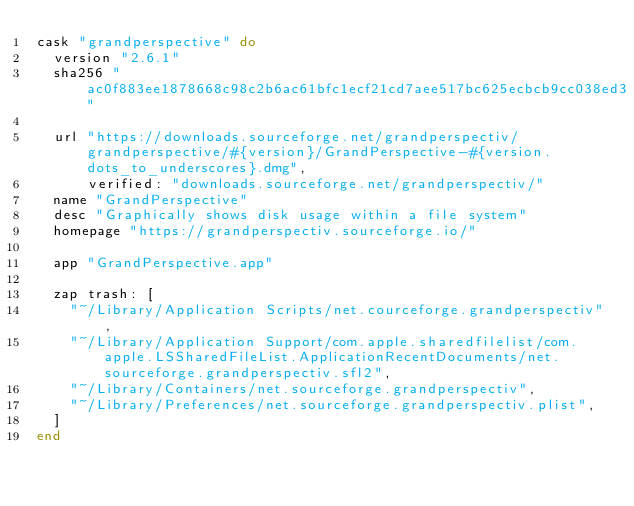<code> <loc_0><loc_0><loc_500><loc_500><_Ruby_>cask "grandperspective" do
  version "2.6.1"
  sha256 "ac0f883ee1878668c98c2b6ac61bfc1ecf21cd7aee517bc625ecbcb9cc038ed3"

  url "https://downloads.sourceforge.net/grandperspectiv/grandperspective/#{version}/GrandPerspective-#{version.dots_to_underscores}.dmg",
      verified: "downloads.sourceforge.net/grandperspectiv/"
  name "GrandPerspective"
  desc "Graphically shows disk usage within a file system"
  homepage "https://grandperspectiv.sourceforge.io/"

  app "GrandPerspective.app"

  zap trash: [
    "~/Library/Application Scripts/net.courceforge.grandperspectiv",
    "~/Library/Application Support/com.apple.sharedfilelist/com.apple.LSSharedFileList.ApplicationRecentDocuments/net.sourceforge.grandperspectiv.sfl2",
    "~/Library/Containers/net.sourceforge.grandperspectiv",
    "~/Library/Preferences/net.sourceforge.grandperspectiv.plist",
  ]
end
</code> 